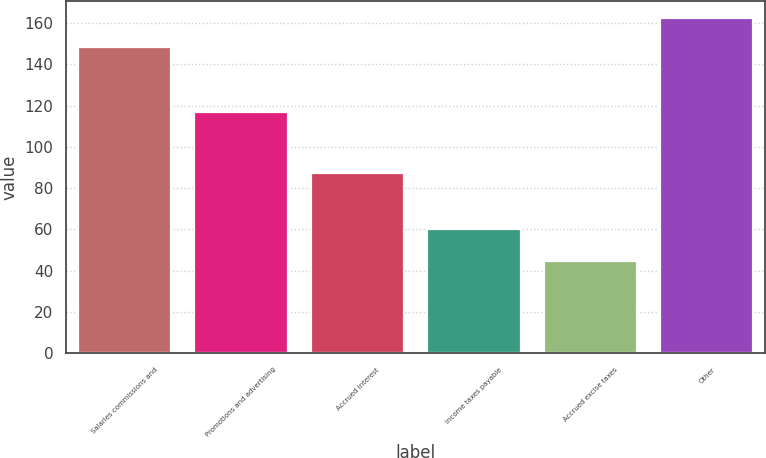<chart> <loc_0><loc_0><loc_500><loc_500><bar_chart><fcel>Salaries commissions and<fcel>Promotions and advertising<fcel>Accrued interest<fcel>Income taxes payable<fcel>Accrued excise taxes<fcel>Other<nl><fcel>148.5<fcel>116.9<fcel>87.5<fcel>60.2<fcel>44.6<fcel>162.7<nl></chart> 